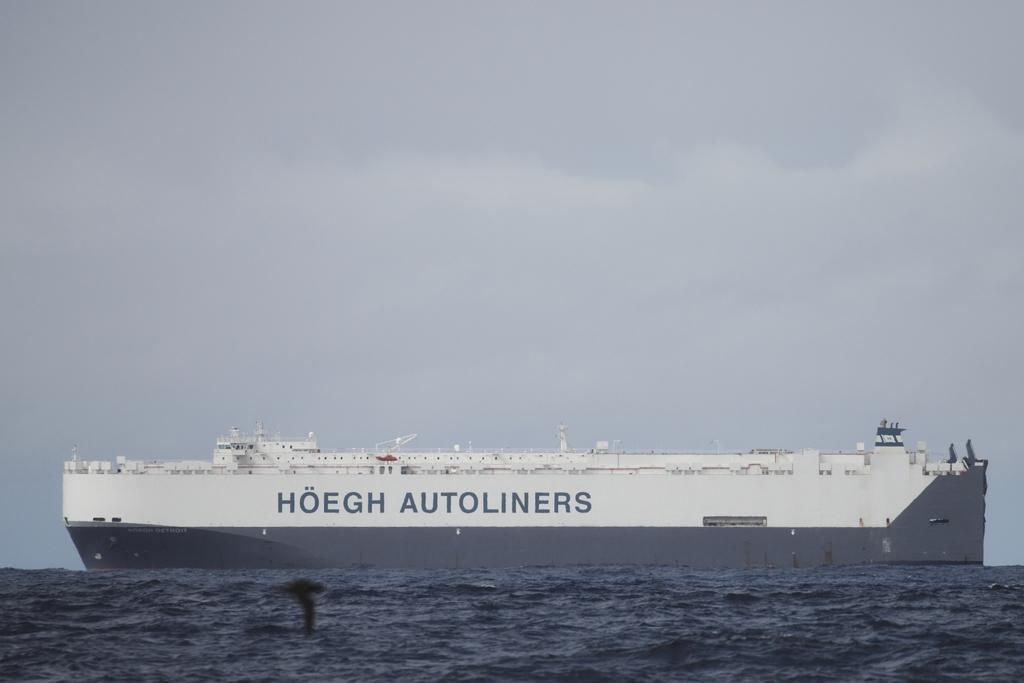What type of vehicle is in the image? There is a cruise-ferry in the image. What is the cruise-ferry doing in the image? The cruise-ferry is moving on the water. Can you describe the environment in which the cruise-ferry is located? The cruise-ferry is on the water, which is likely to be the sea, although this cannot be confirmed without additional context. Where is the drawer located in the image? There is no drawer present in the image. What is the way the sky is depicted in the image? The sky is not depicted in the image, as the focus is on the cruise-ferry and the water. 